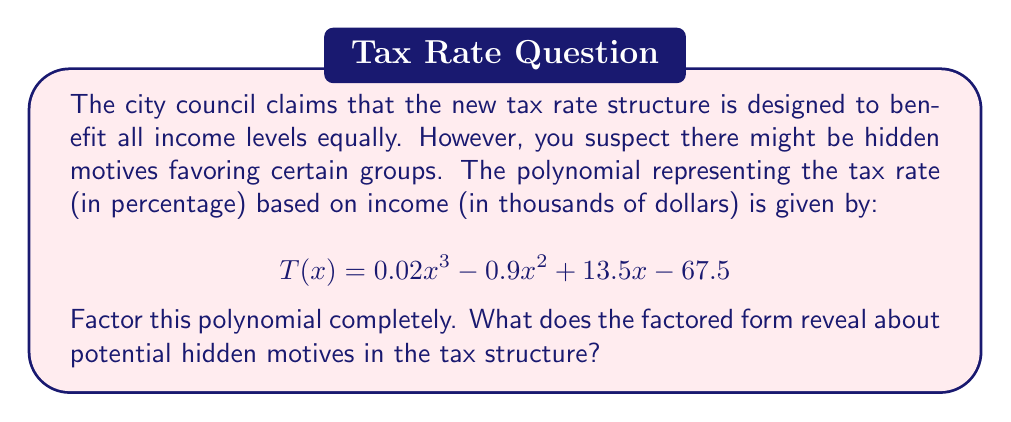Can you solve this math problem? To uncover potential hidden motives in the tax structure, we need to factor the given polynomial completely. Let's approach this step-by-step:

1) First, let's check if there are any common factors:
   $$T(x) = 0.02x^3 - 0.9x^2 + 13.5x - 67.5$$
   There are no common factors for all terms.

2) Next, let's try to guess a factor. Often, the constant term (-67.5) is a product of factors. Let's try $x - 4.5$:

   $$T(4.5) = 0.02(4.5)^3 - 0.9(4.5)^2 + 13.5(4.5) - 67.5 = 0$$

   So, $(x - 4.5)$ is indeed a factor.

3) We can now use polynomial long division to find the other factor:

   $$\frac{T(x)}{x - 4.5} = 0.02x^2 + 0.02x + 0.6$$

4) Therefore, we can write:
   $$T(x) = (x - 4.5)(0.02x^2 + 0.02x + 0.6)$$

5) The quadratic factor can be further factored using the quadratic formula:
   $$0.02x^2 + 0.02x + 0.6 = 0.02(x^2 + x + 30)$$
   $$x = \frac{-1 \pm \sqrt{1^2 - 4(1)(30)}}{2(1)} = \frac{-1 \pm \sqrt{-119}}{2}$$

   This has no real roots, so it can't be factored further over the real numbers.

6) Our final factored form is:
   $$T(x) = 0.02(x - 4.5)(x^2 + x + 30)$$

This factored form reveals that:

a) There's a root at $x = 4.5$, meaning individuals earning $4,500 per year would pay no taxes.
b) The tax rate increases rapidly for incomes above $4,500 due to the quadratic and cubic terms.
c) The factor $(x^2 + x + 30)$ ensures the tax rate is always positive for incomes above $4,500.

These findings suggest a potential hidden motive to provide a tax break for very low-income earners (below $4,500), while rapidly increasing taxes on middle and high-income earners.
Answer: $$T(x) = 0.02(x - 4.5)(x^2 + x + 30)$$
This factored form reveals a potential hidden motive to exempt very low incomes (below $4,500 annually) from taxes while rapidly increasing the tax rate for higher incomes. 